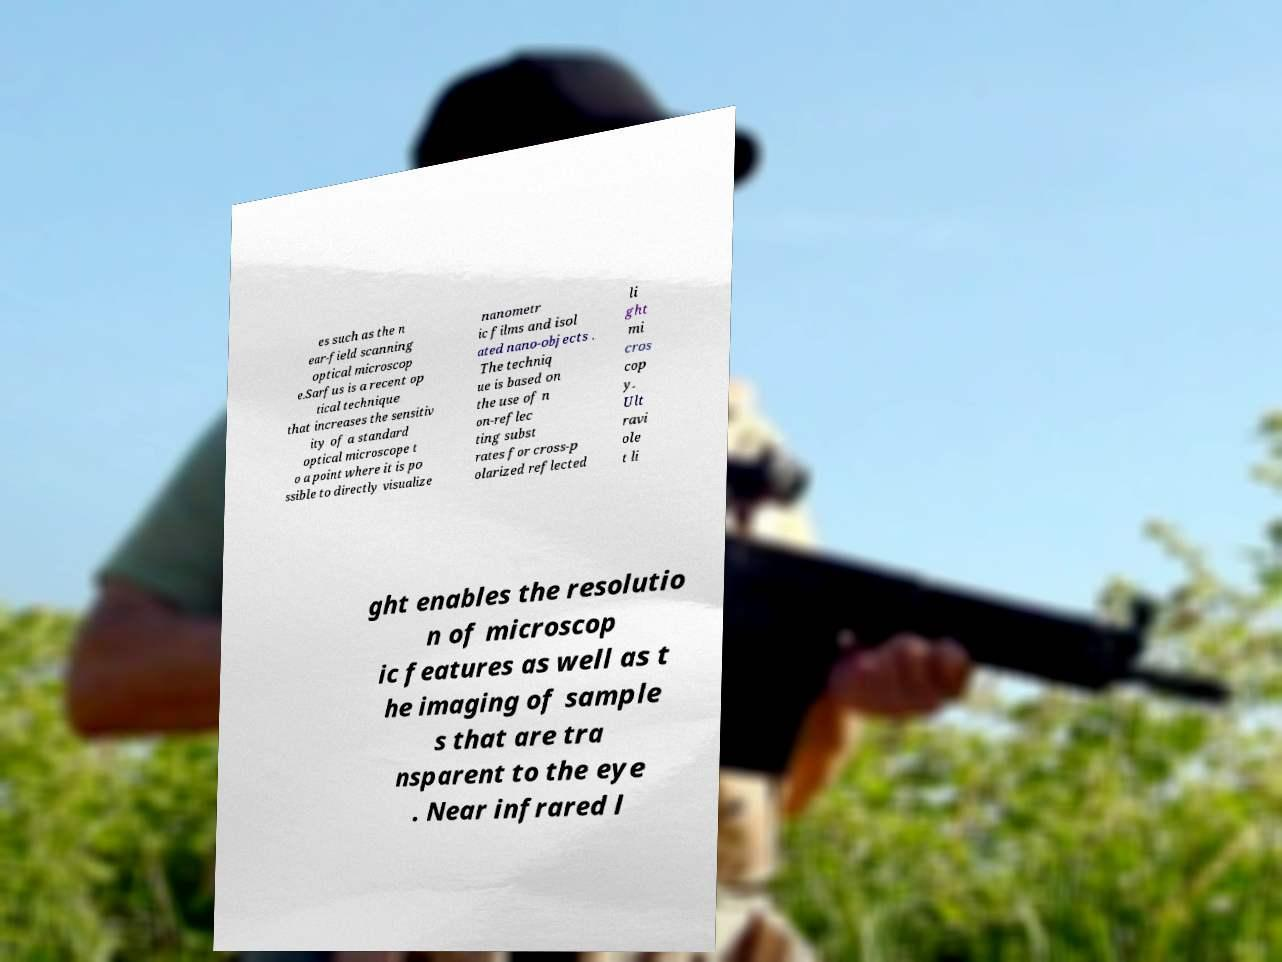What messages or text are displayed in this image? I need them in a readable, typed format. es such as the n ear-field scanning optical microscop e.Sarfus is a recent op tical technique that increases the sensitiv ity of a standard optical microscope t o a point where it is po ssible to directly visualize nanometr ic films and isol ated nano-objects . The techniq ue is based on the use of n on-reflec ting subst rates for cross-p olarized reflected li ght mi cros cop y. Ult ravi ole t li ght enables the resolutio n of microscop ic features as well as t he imaging of sample s that are tra nsparent to the eye . Near infrared l 